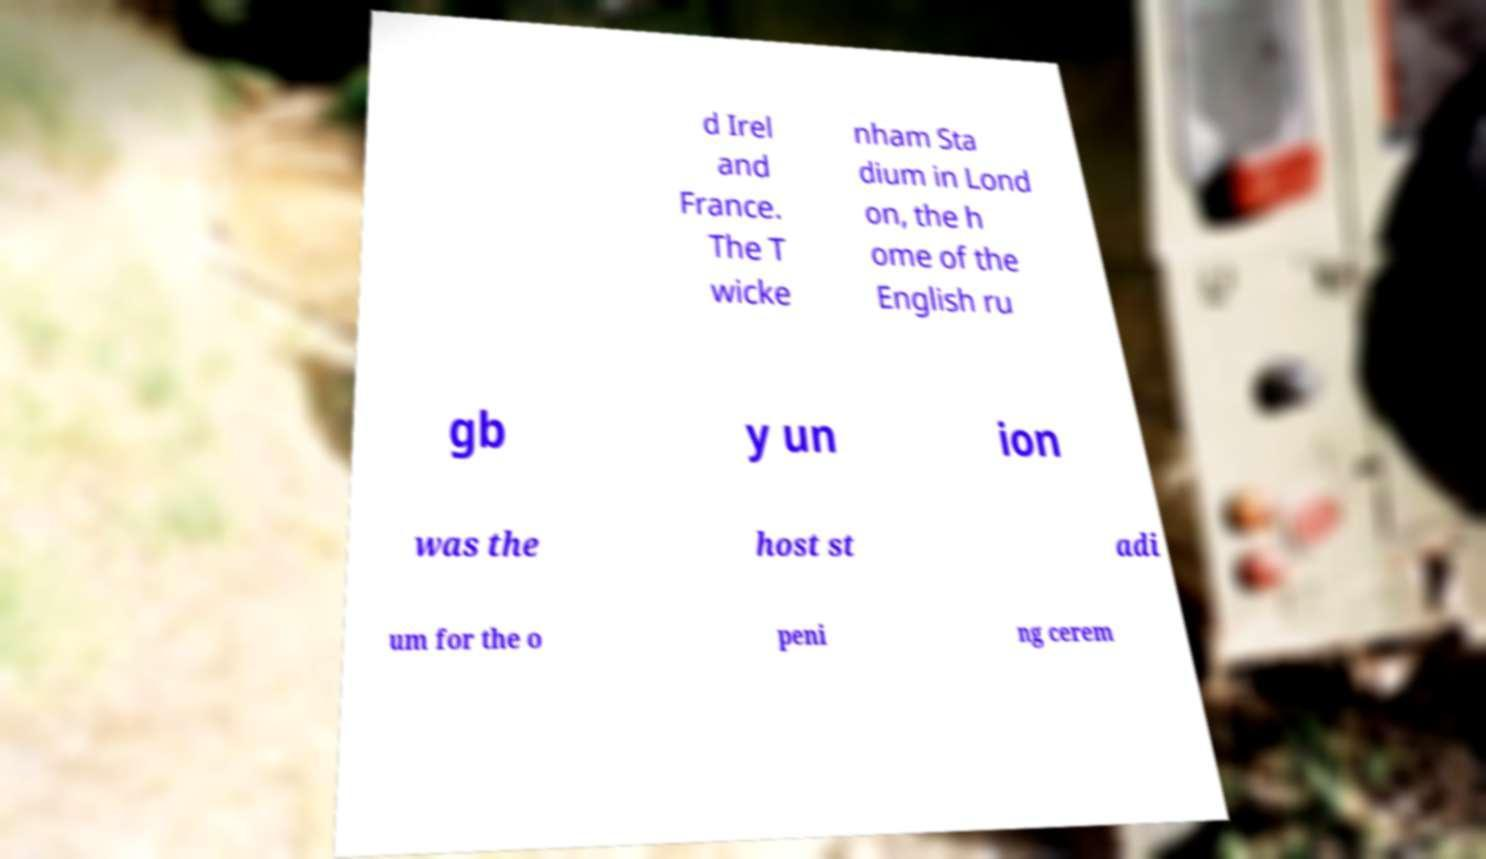For documentation purposes, I need the text within this image transcribed. Could you provide that? d Irel and France. The T wicke nham Sta dium in Lond on, the h ome of the English ru gb y un ion was the host st adi um for the o peni ng cerem 